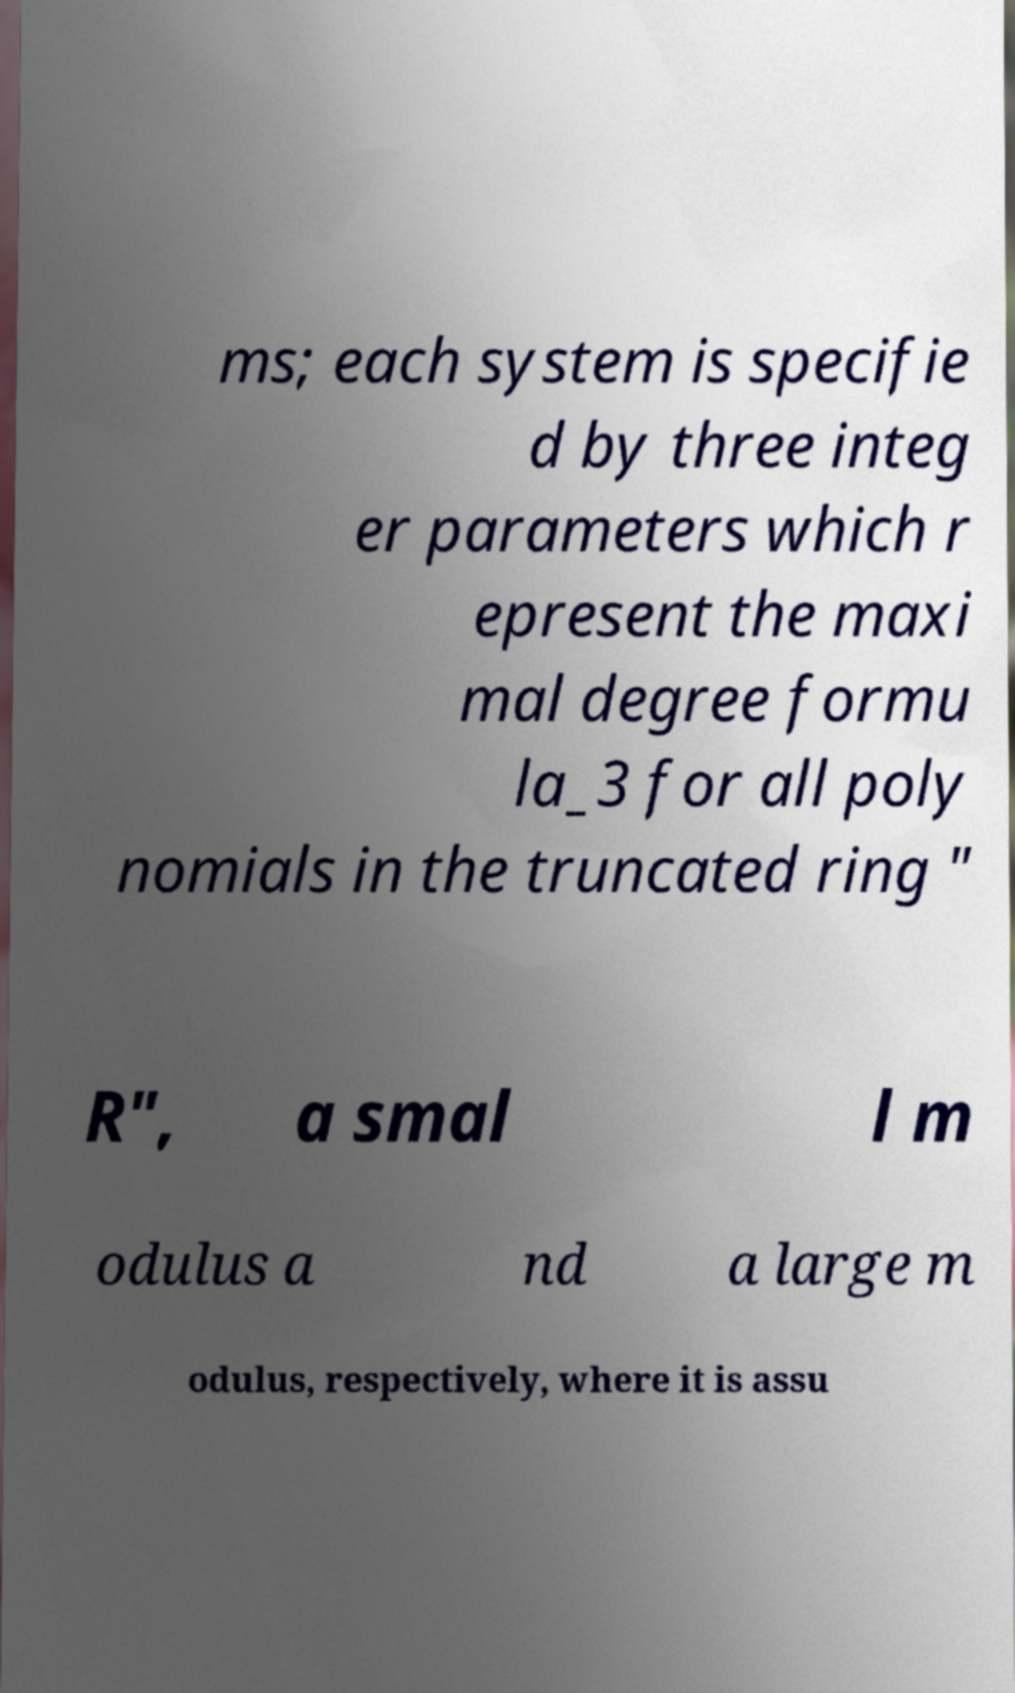Could you assist in decoding the text presented in this image and type it out clearly? ms; each system is specifie d by three integ er parameters which r epresent the maxi mal degree formu la_3 for all poly nomials in the truncated ring " R", a smal l m odulus a nd a large m odulus, respectively, where it is assu 